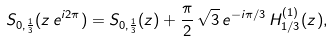Convert formula to latex. <formula><loc_0><loc_0><loc_500><loc_500>S _ { 0 , \frac { 1 } { 3 } } ( z \, e ^ { i 2 \pi } ) = S _ { 0 , \frac { 1 } { 3 } } ( z ) + \frac { \pi } { 2 } \, \sqrt { 3 } \, e ^ { - i \pi / 3 } \, H _ { 1 / 3 } ^ { ( 1 ) } ( z ) ,</formula> 